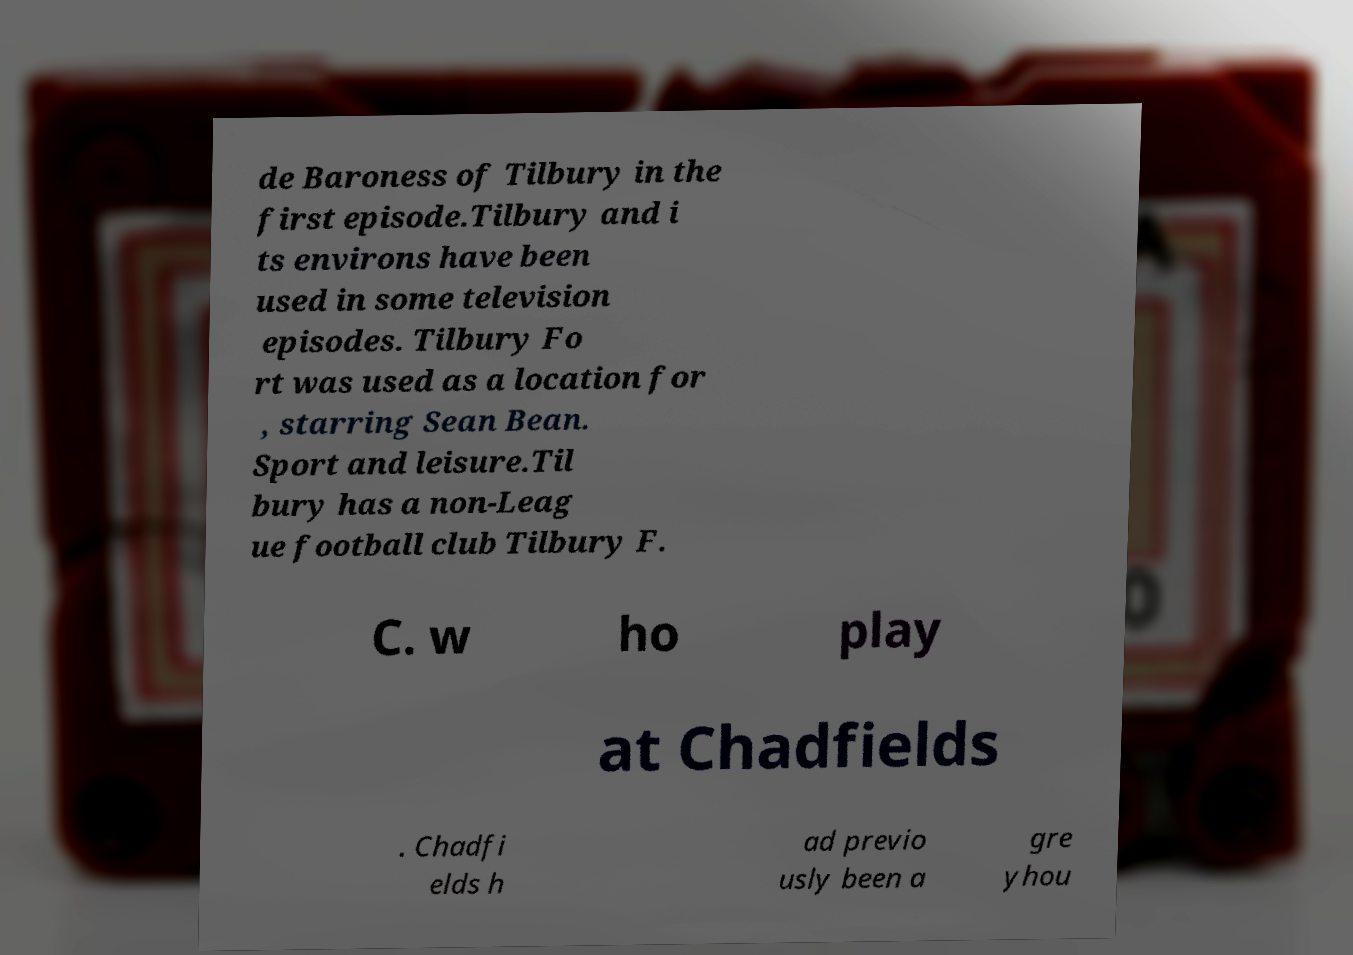There's text embedded in this image that I need extracted. Can you transcribe it verbatim? de Baroness of Tilbury in the first episode.Tilbury and i ts environs have been used in some television episodes. Tilbury Fo rt was used as a location for , starring Sean Bean. Sport and leisure.Til bury has a non-Leag ue football club Tilbury F. C. w ho play at Chadfields . Chadfi elds h ad previo usly been a gre yhou 